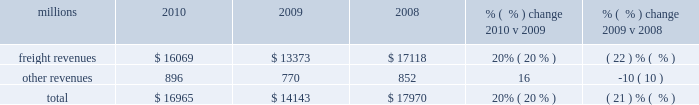Us in a position to handle demand changes .
We will also continue utilizing industrial engineering techniques to improve productivity .
2022 fuel prices 2013 uncertainty about the economy makes fuel price projections difficult , and we could see volatile fuel prices during the year , as they are sensitive to global and u.s .
Domestic demand , refining capacity , geopolitical events , weather conditions and other factors .
To reduce the impact of fuel price on earnings , we will continue to seek recovery from our customers through our fuel surcharge programs and to expand our fuel conservation efforts .
2022 capital plan 2013 in 2011 , we plan to make total capital investments of approximately $ 3.2 billion , including expenditures for positive train control ( ptc ) , which may be revised if business conditions warrant or if new laws or regulations affect our ability to generate sufficient returns on these investments .
( see further discussion in this item 7 under liquidity and capital resources 2013 capital plan. ) 2022 positive train control 2013 in response to a legislative mandate to implement ptc by the end of 2015 , we expect to spend approximately $ 250 million during 2011 on developing ptc .
We currently estimate that ptc will cost us approximately $ 1.4 billion to implement by the end of 2015 , in accordance with rules issued by the federal railroad administration ( fra ) .
This includes costs for installing the new system along our tracks , upgrading locomotives to work with the new system , and adding digital data communication equipment so all the parts of the system can communicate with each other .
During 2011 , we plan to begin testing the technology to evaluate its effectiveness .
2022 financial expectations 2013 we remain cautious about economic conditions , but anticipate volume to increase from 2010 levels .
In addition , we expect volume , price , and productivity gains to offset expected higher costs for fuel , labor inflation , depreciation , casualty costs , and property taxes to drive operating ratio improvement .
Results of operations operating revenues millions 2010 2009 2008 % (  % ) change 2010 v 2009 % (  % ) change 2009 v 2008 .
Freight revenues are revenues generated by transporting freight or other materials from our six commodity groups .
Freight revenues vary with volume ( carloads ) and average revenue per car ( arc ) .
Changes in price , traffic mix and fuel surcharges drive arc .
We provide some of our customers with contractual incentives for meeting or exceeding specified cumulative volumes or shipping to and from specific locations , which we record as a reduction to freight revenues based on the actual or projected future shipments .
We recognize freight revenues as freight moves from origin to destination .
We allocate freight revenues between reporting periods based on the relative transit time in each reporting period and recognize expenses as we incur them .
Other revenues include revenues earned by our subsidiaries , revenues from our commuter rail operations , and accessorial revenues , which we earn when customers retain equipment owned or controlled by us or when we perform additional services such as switching or storage .
We recognize other revenues as we perform services or meet contractual obligations .
Freight revenues and volume levels for all six commodity groups increased during 2010 as a result of economic improvement in many market sectors .
We experienced particularly strong volume growth in automotive , intermodal , and industrial products shipments .
Core pricing gains and higher fuel surcharges also increased freight revenues and drove a 6% ( 6 % ) improvement in arc .
Freight revenues and volume levels for all six commodity groups decreased during 2009 , reflecting continued economic weakness .
We experienced the largest volume declines in automotive and industrial .
What is the average operating revenue from 2008-2010 , in millions? 
Computations: (((16965 + 14143) + 17970) / 3)
Answer: 16359.33333. 